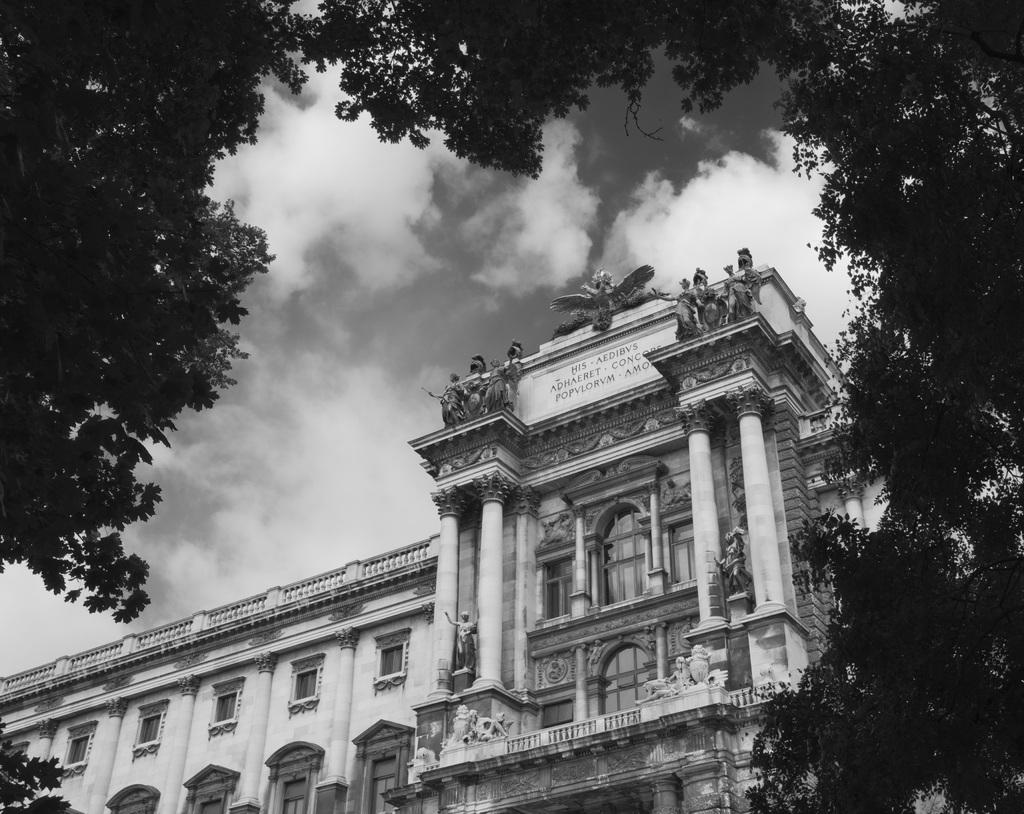What type of structure is visible in the image? There is a building in the image. What other natural elements can be seen in the image? There are trees in the image. What is visible in the background of the image? The sky is visible in the background of the image. What can be observed in the sky? Clouds are present in the sky. What type of canvas is hanging on the building in the image? There is no canvas present in the image; it features a building, trees, and a sky with clouds. 